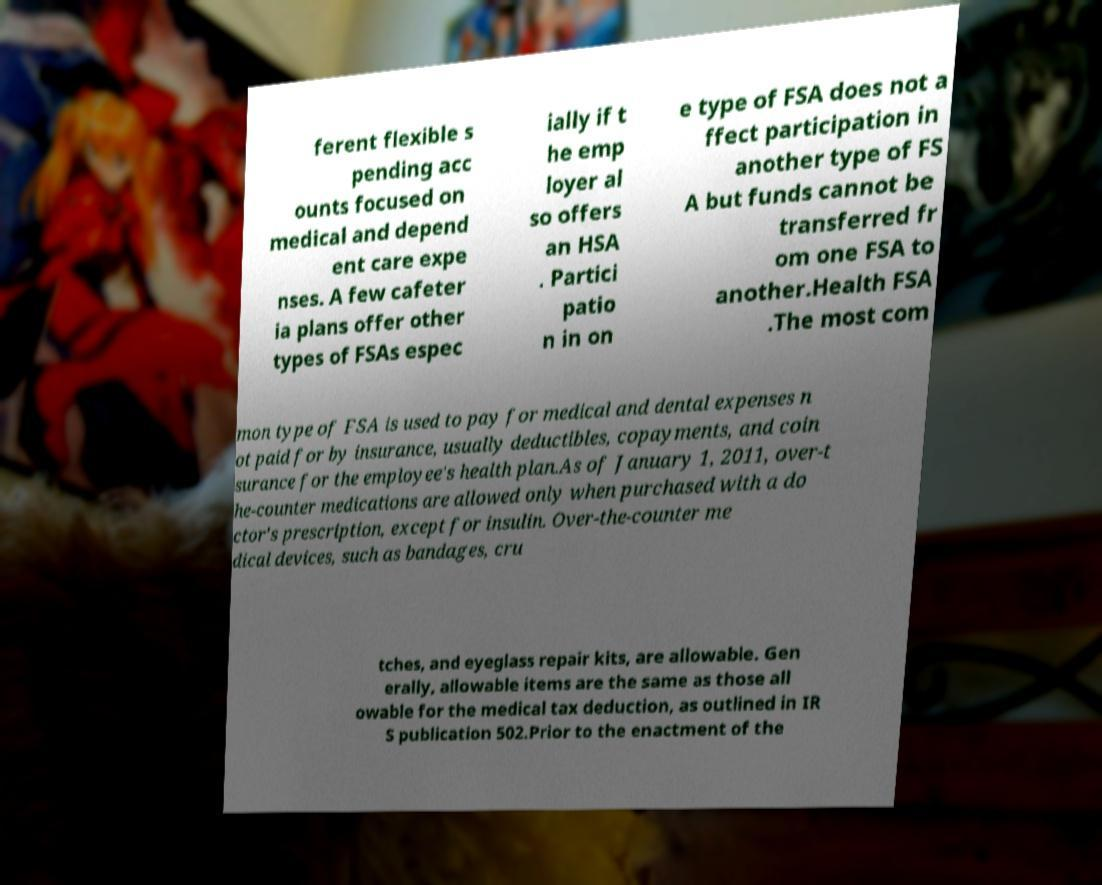What messages or text are displayed in this image? I need them in a readable, typed format. ferent flexible s pending acc ounts focused on medical and depend ent care expe nses. A few cafeter ia plans offer other types of FSAs espec ially if t he emp loyer al so offers an HSA . Partici patio n in on e type of FSA does not a ffect participation in another type of FS A but funds cannot be transferred fr om one FSA to another.Health FSA .The most com mon type of FSA is used to pay for medical and dental expenses n ot paid for by insurance, usually deductibles, copayments, and coin surance for the employee's health plan.As of January 1, 2011, over-t he-counter medications are allowed only when purchased with a do ctor's prescription, except for insulin. Over-the-counter me dical devices, such as bandages, cru tches, and eyeglass repair kits, are allowable. Gen erally, allowable items are the same as those all owable for the medical tax deduction, as outlined in IR S publication 502.Prior to the enactment of the 